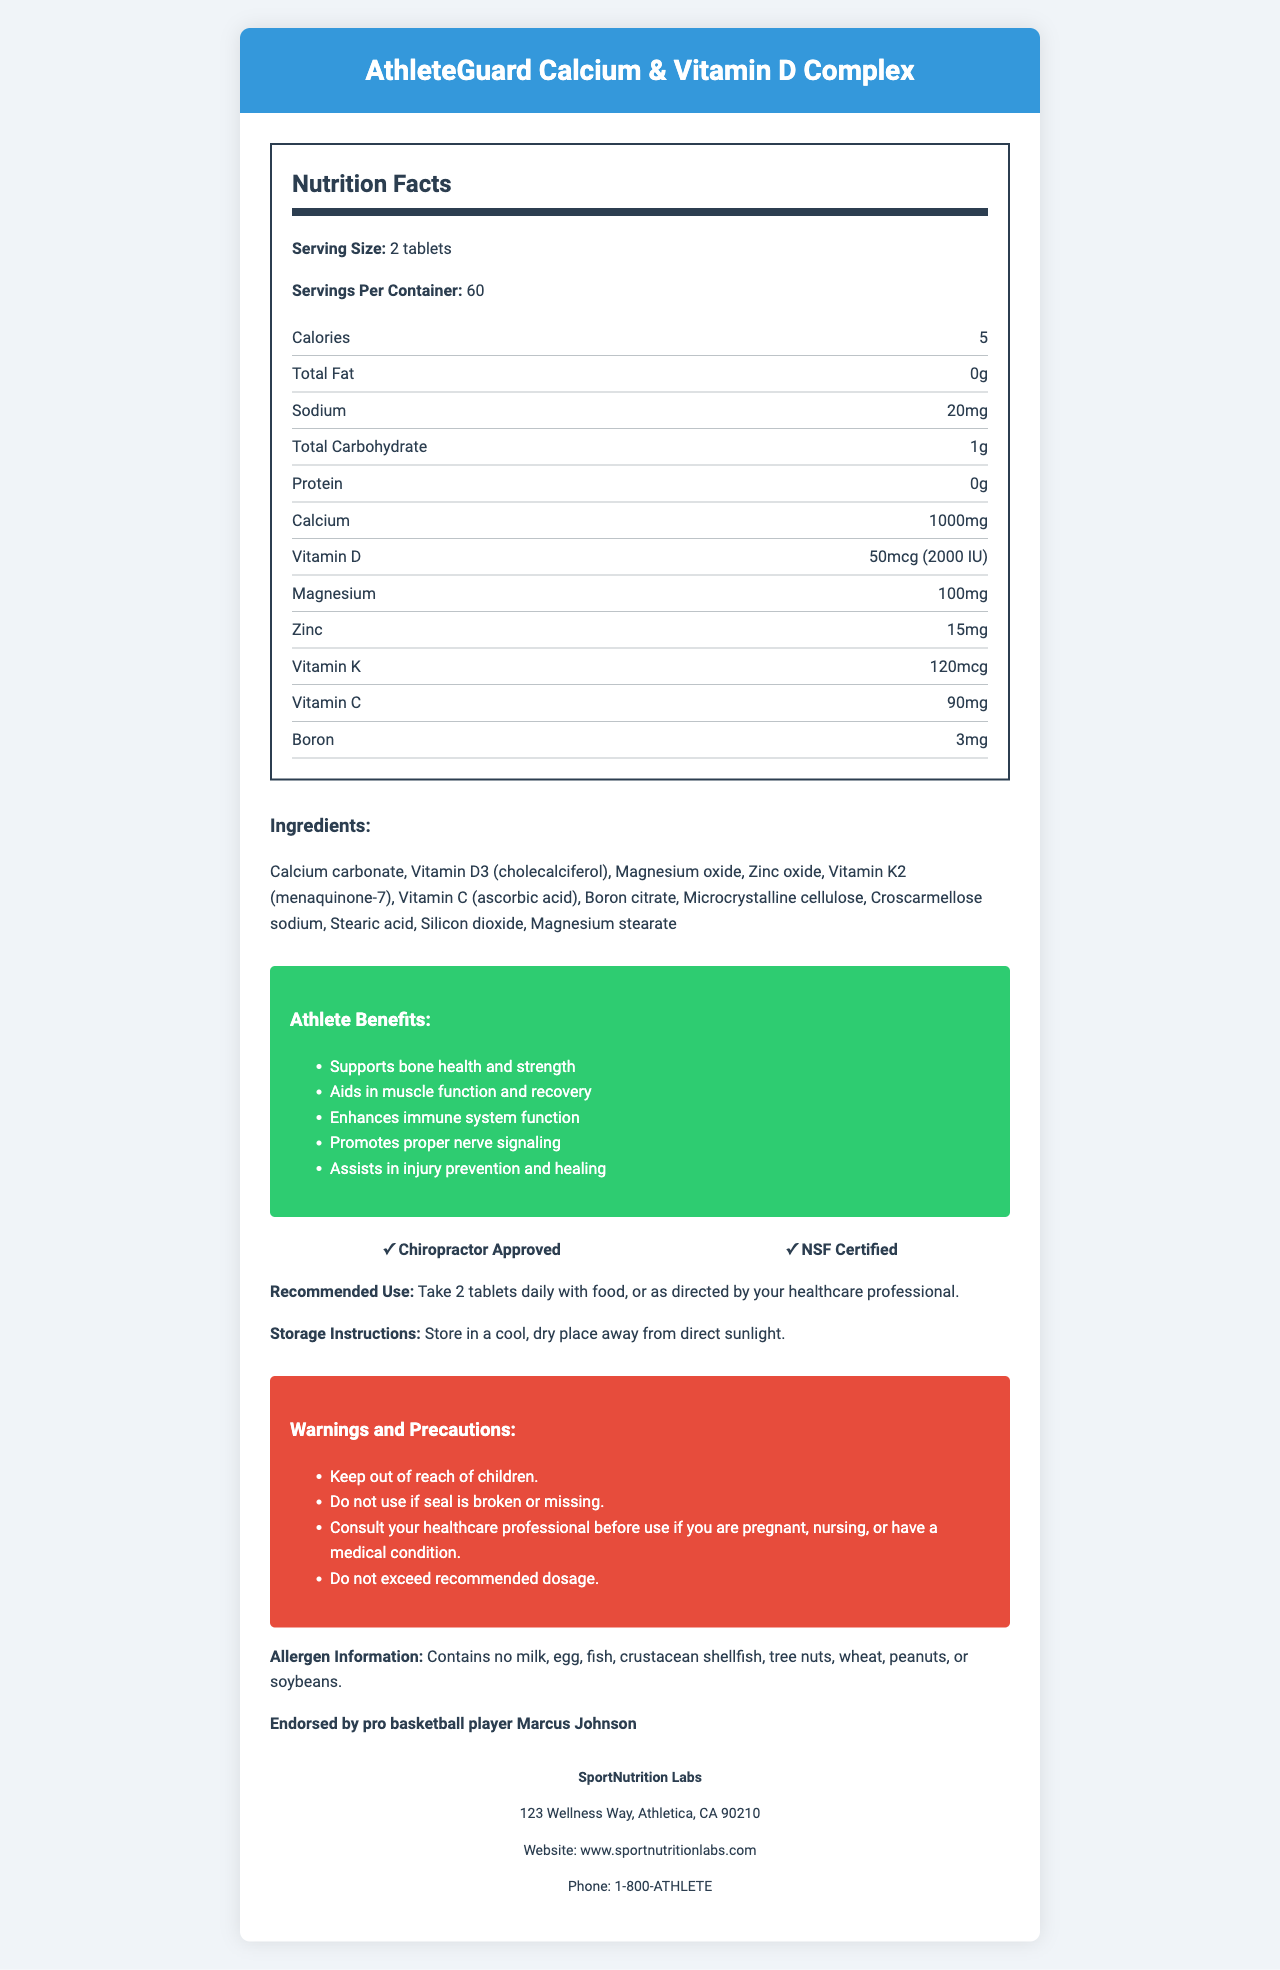what is the serving size for AthleteGuard Calcium & Vitamin D Complex? The document states that the serving size is 2 tablets.
Answer: 2 tablets how many calories are in each serving? The document specifies that each serving contains 5 calories.
Answer: 5 calories how much calcium is provided per serving? The document notes that each serving contains 1000mg of calcium.
Answer: 1000mg what is the total carbohydrate content per serving? The document mentions that each serving contains 1g of total carbohydrates.
Answer: 1g what is the recommended use for AthleteGuard Calcium & Vitamin D Complex? The document states that the recommended use is to take 2 tablets daily with food, or as directed by your healthcare professional.
Answer: Take 2 tablets daily with food, or as directed by your healthcare professional. which of the following is an ingredient in AthleteGuard Calcium & Vitamin D Complex? A. Vitamin B12 B. Vitamin E C. Boron citrate The ingredients listed in the document include Boron citrate, but not Vitamin B12 or Vitamin E.
Answer: C. Boron citrate what is the benefit of taking AthleteGuard Calcium & Vitamin D Complex related to immune function? A. Aids in muscle function B. Enhances immune system function C. Promotes bone health The document states that one of the athlete benefits is enhancing immune system function.
Answer: B. Enhances immune system function is the product endorsed by a professional basketball player? The document indicates that the product is endorsed by pro basketball player Marcus Johnson.
Answer: Yes are there any allergen warnings for this supplement? The document states that the product contains no milk, egg, fish, crustacean shellfish, tree nuts, wheat, peanuts, or soybeans.
Answer: Contains no milk, egg, fish, crustacean shellfish, tree nuts, wheat, peanuts, or soybeans. provide a summary of the AthleteGuard Calcium & Vitamin D Complex document The document offers a comprehensive overview of the supplement, from its nutritional content and recommended use to its benefits and endorsements, covering all aspects essential for athletes and health professionals.
Answer: The document provides detailed information about AthleteGuard Calcium & Vitamin D Complex, a supplement from SportNutrition Labs designed to aid athletes in injury prevention, support bone health, and improve muscle function and immune system performance. It includes nutritional facts, ingredients, athlete benefits, usage instructions, storage instructions, warnings, and manufacturer information. The product is chiropractor approved, NSF certified, and endorsed by pro basketball player Marcus Johnson. what's the magnesium content per serving? The document lists that each serving contains 100mg of magnesium.
Answer: 100mg how should the product be stored? The document advises to store the product in a cool, dry place away from direct sunlight.
Answer: Store in a cool, dry place away from direct sunlight. provide the phone number of the manufacturer of AthleteGuard Calcium & Vitamin D Complex The document provides the manufacturer's phone number as 1-800-ATHLETE.
Answer: 1-800-ATHLETE does the product support injury prevention in athletes? The document includes assisting in injury prevention and healing as one of the benefits for athletes.
Answer: Yes how many servings does one container provide? The document states that there are 60 servings per container.
Answer: 60 list all the vitamins included in the supplement The document lists Vitamin D, Vitamin K2, and Vitamin C as part of the nutrients in the supplement.
Answer: Vitamin D, Vitamin K, Vitamin C what is the cautionary advice for pregnant individuals? The document advises pregnant individuals to consult their healthcare professional before using the product.
Answer: Consult your healthcare professional before use if you are pregnant, nursing, or have a medical condition. is this product suitable for individuals with soy allergies? The document states that the product contains no soybeans.
Answer: Yes what is the street address of SportNutrition Labs? The document provides the manufacturer's address as 123 Wellness Way, Athletica, CA 90210.
Answer: 123 Wellness Way, Athletica, CA 90210 what is the dosage of Vitamin D in IU per serving? The document mentions that each serving contains 50mcg of Vitamin D, which is equivalent to 2000 IU.
Answer: 2000 IU does the product include Vitamin B12? The document does not mention Vitamin B12 in the list of nutrients or ingredients, so this cannot be determined from the provided details.
Answer: Not enough information 